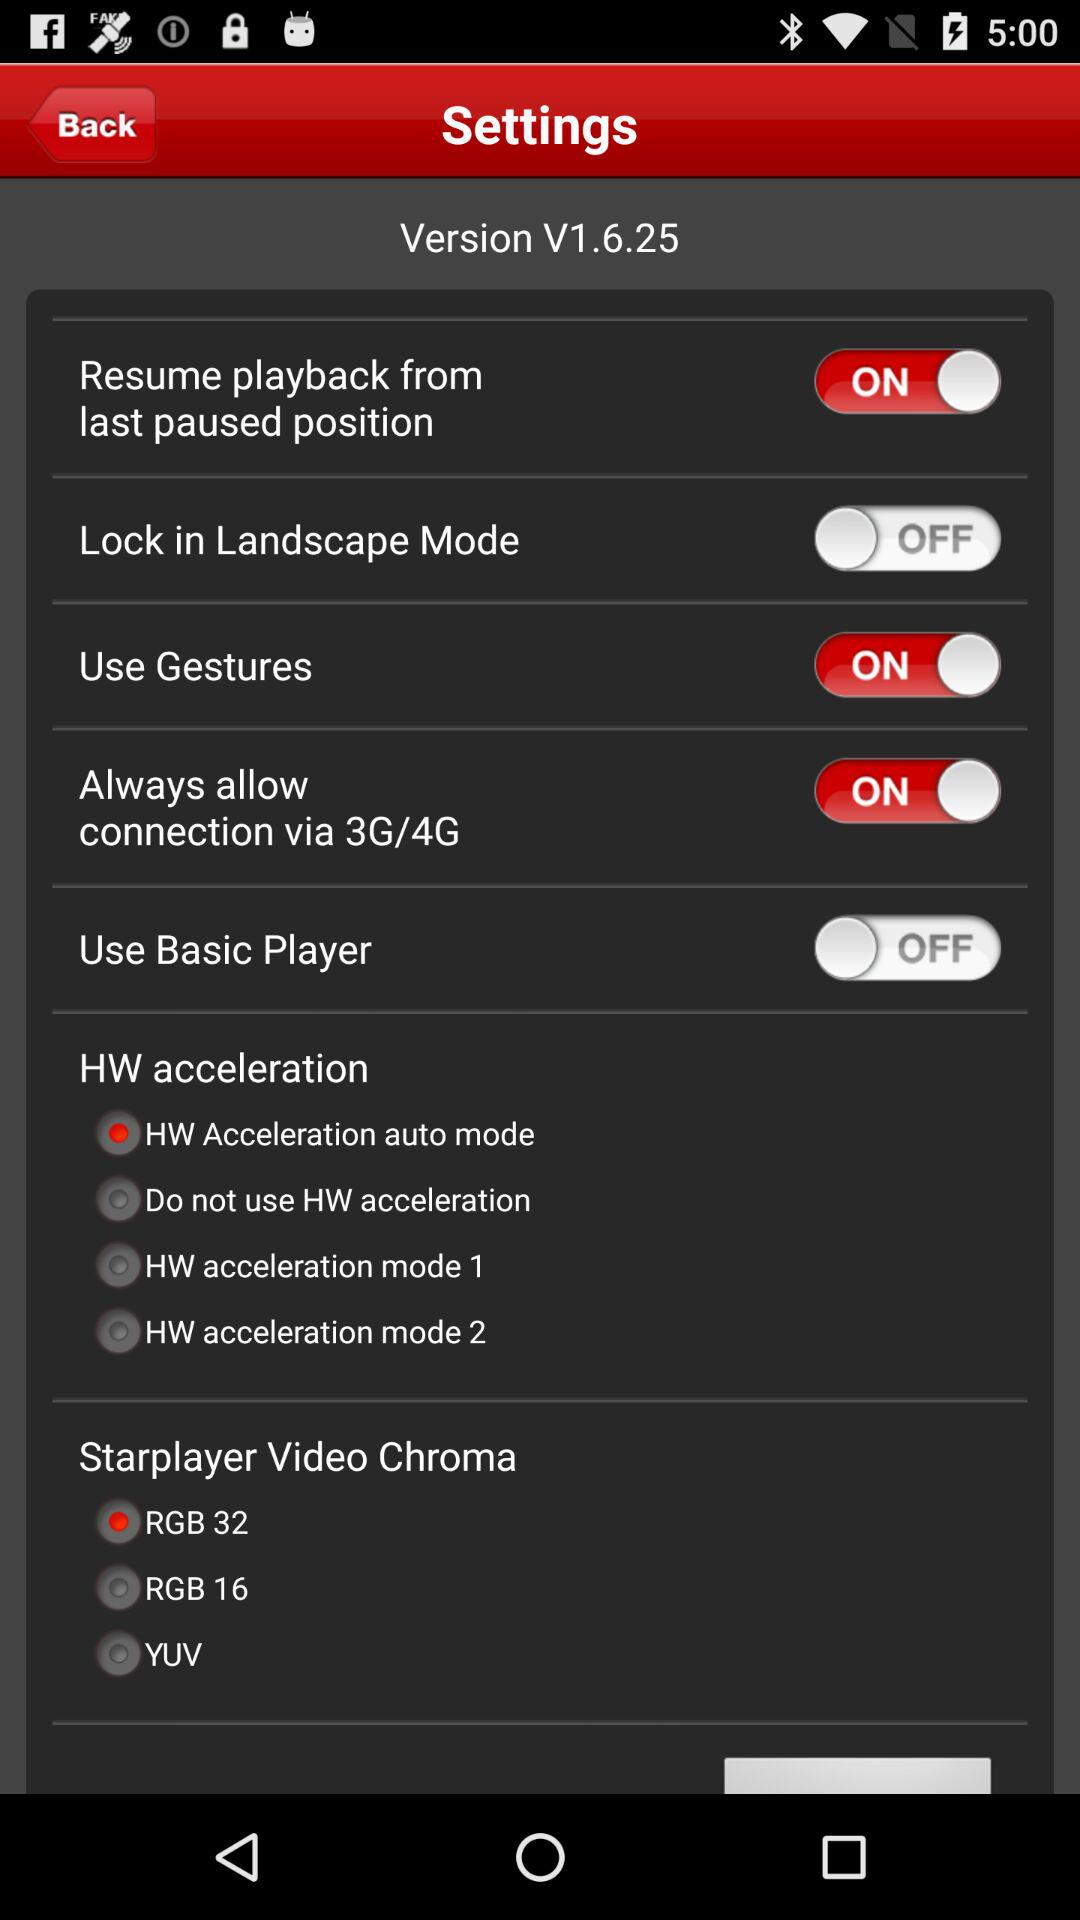Which option is selected for "HW acceleration"? The option that is selected for "HW acceleration" is "HW Acceleration auto mode". 